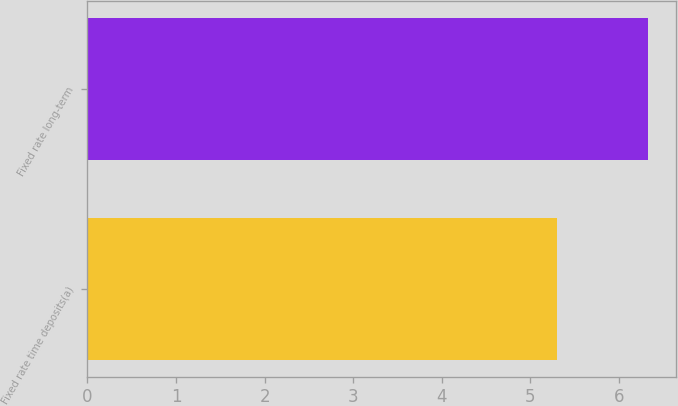Convert chart to OTSL. <chart><loc_0><loc_0><loc_500><loc_500><bar_chart><fcel>Fixed rate time deposits(a)<fcel>Fixed rate long-term<nl><fcel>5.3<fcel>6.33<nl></chart> 